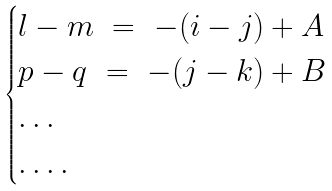<formula> <loc_0><loc_0><loc_500><loc_500>\begin{cases} l - m \ = \ - ( i - j ) + A \\ p - q \ = \ - ( j - k ) + B \\ \dots \\ \dots . \\ \end{cases}</formula> 